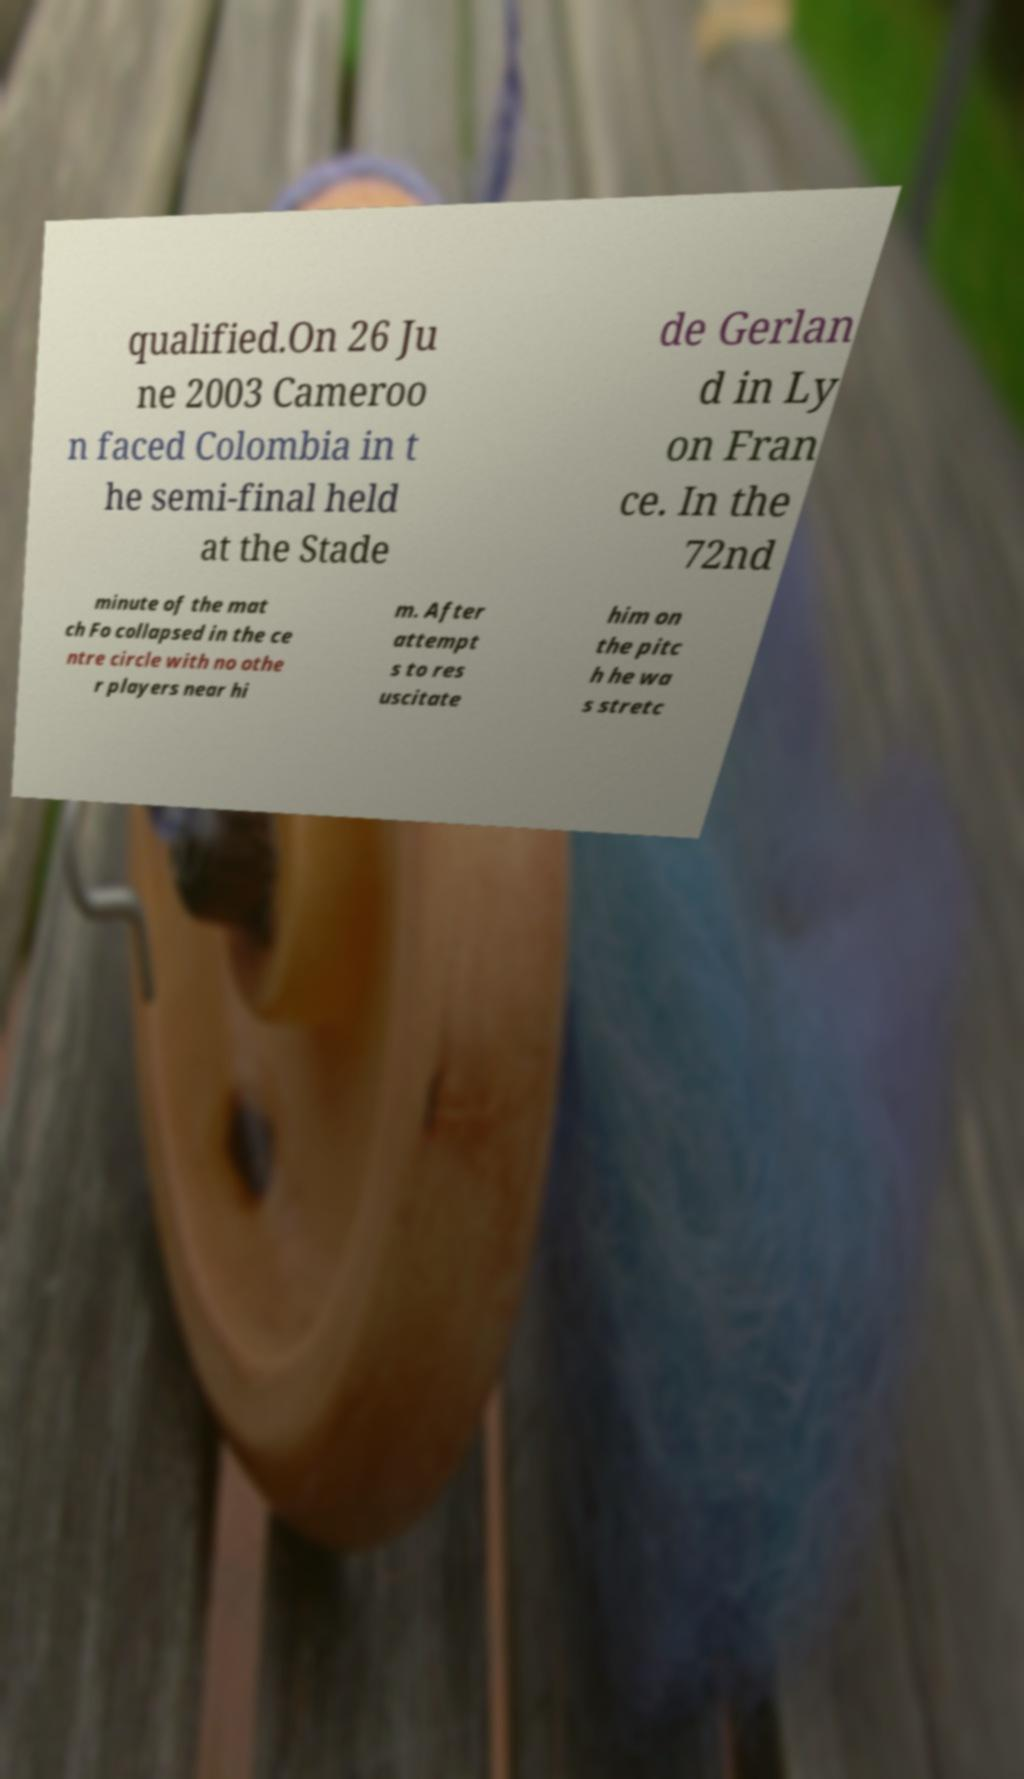Could you assist in decoding the text presented in this image and type it out clearly? qualified.On 26 Ju ne 2003 Cameroo n faced Colombia in t he semi-final held at the Stade de Gerlan d in Ly on Fran ce. In the 72nd minute of the mat ch Fo collapsed in the ce ntre circle with no othe r players near hi m. After attempt s to res uscitate him on the pitc h he wa s stretc 